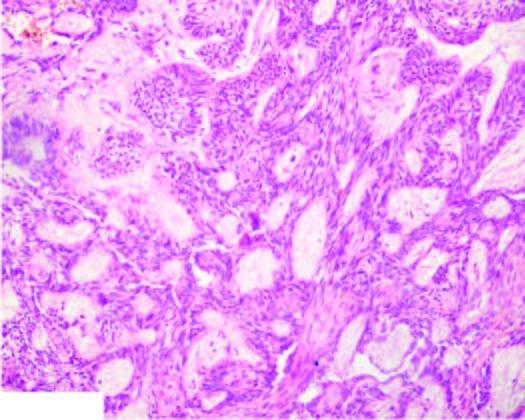re eticulocytes in blood composed of central area of stellate cells and peripheral layer of cuboidal or columnar cells?
Answer the question using a single word or phrase. No 